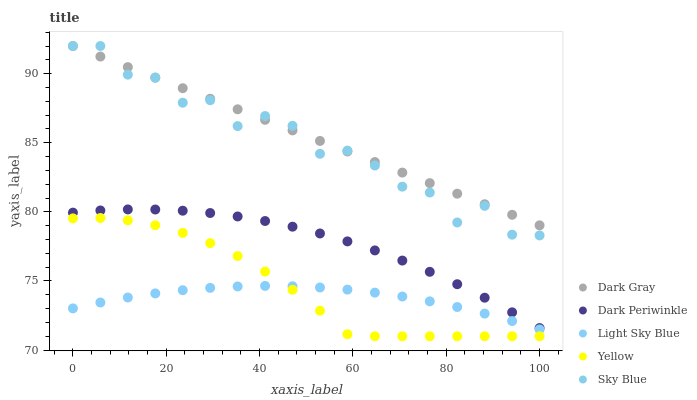Does Light Sky Blue have the minimum area under the curve?
Answer yes or no. Yes. Does Dark Gray have the maximum area under the curve?
Answer yes or no. Yes. Does Sky Blue have the minimum area under the curve?
Answer yes or no. No. Does Sky Blue have the maximum area under the curve?
Answer yes or no. No. Is Dark Gray the smoothest?
Answer yes or no. Yes. Is Sky Blue the roughest?
Answer yes or no. Yes. Is Light Sky Blue the smoothest?
Answer yes or no. No. Is Light Sky Blue the roughest?
Answer yes or no. No. Does Yellow have the lowest value?
Answer yes or no. Yes. Does Sky Blue have the lowest value?
Answer yes or no. No. Does Sky Blue have the highest value?
Answer yes or no. Yes. Does Light Sky Blue have the highest value?
Answer yes or no. No. Is Yellow less than Dark Gray?
Answer yes or no. Yes. Is Dark Gray greater than Light Sky Blue?
Answer yes or no. Yes. Does Yellow intersect Light Sky Blue?
Answer yes or no. Yes. Is Yellow less than Light Sky Blue?
Answer yes or no. No. Is Yellow greater than Light Sky Blue?
Answer yes or no. No. Does Yellow intersect Dark Gray?
Answer yes or no. No. 